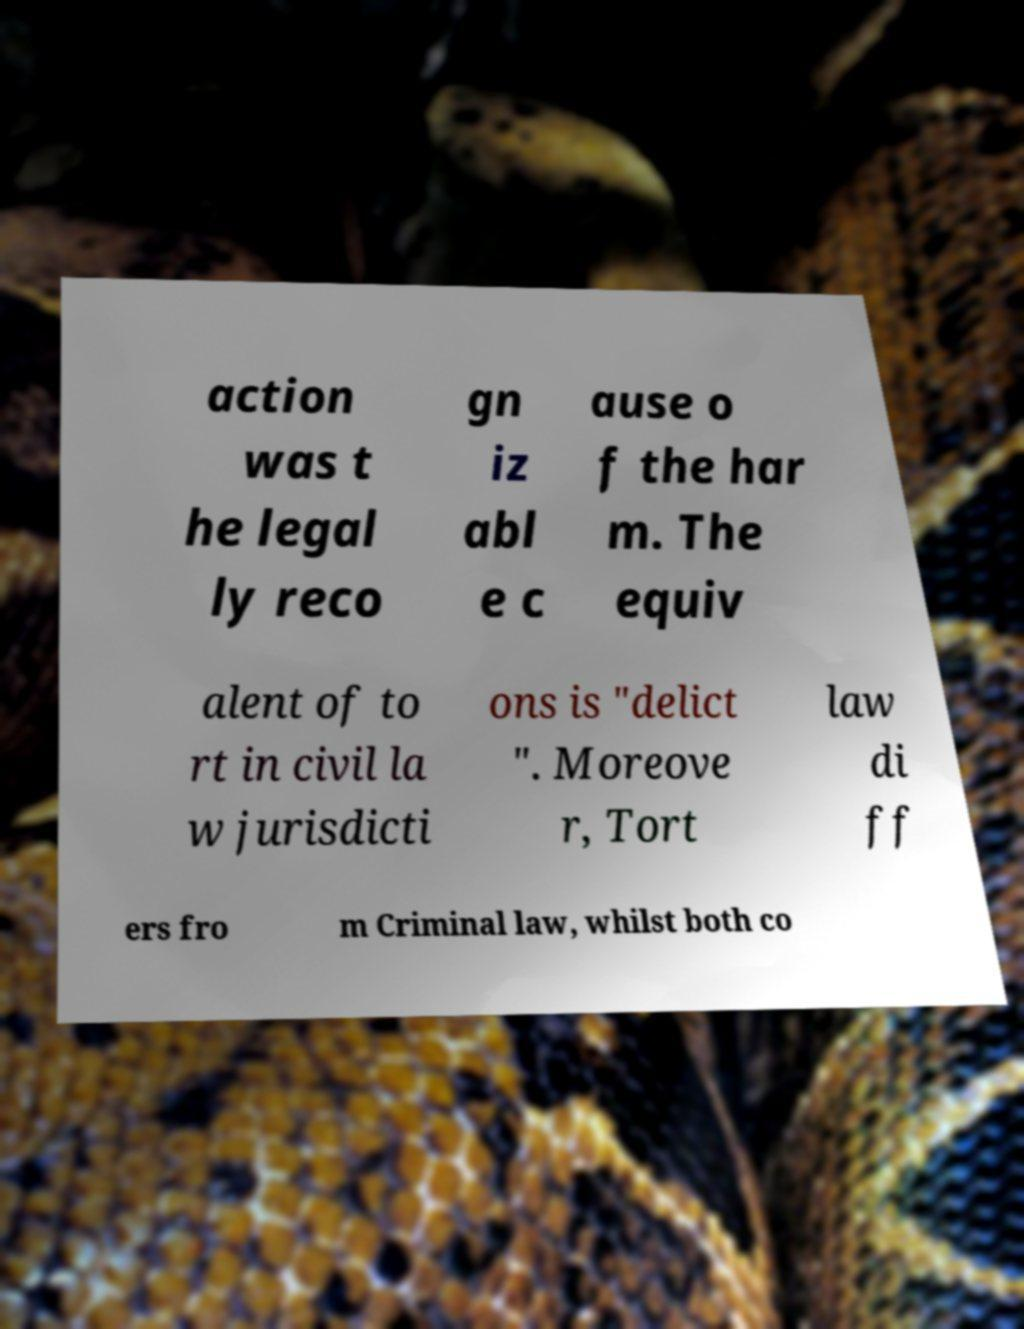For documentation purposes, I need the text within this image transcribed. Could you provide that? action was t he legal ly reco gn iz abl e c ause o f the har m. The equiv alent of to rt in civil la w jurisdicti ons is "delict ". Moreove r, Tort law di ff ers fro m Criminal law, whilst both co 